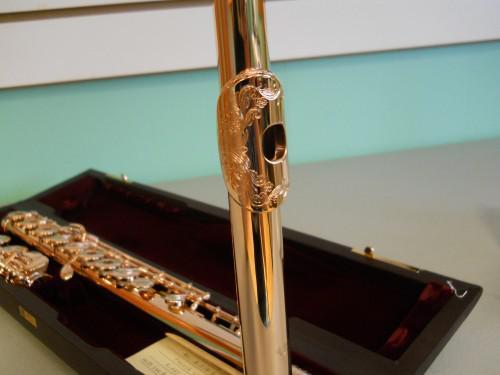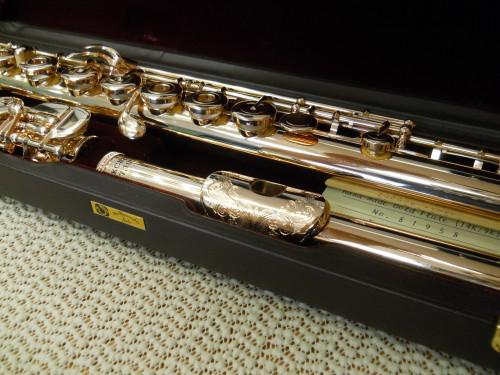The first image is the image on the left, the second image is the image on the right. Examine the images to the left and right. Is the description "All the flutes are assembled." accurate? Answer yes or no. No. The first image is the image on the left, the second image is the image on the right. Assess this claim about the two images: "One image shows a shiny pale gold flute in parts inside an open case.". Correct or not? Answer yes or no. Yes. 